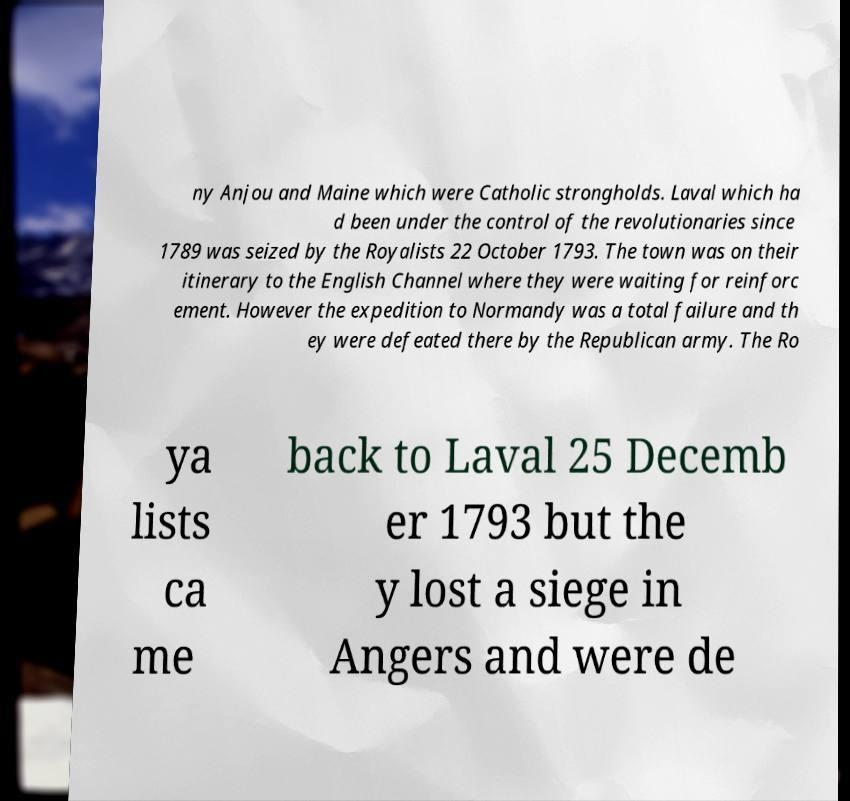There's text embedded in this image that I need extracted. Can you transcribe it verbatim? ny Anjou and Maine which were Catholic strongholds. Laval which ha d been under the control of the revolutionaries since 1789 was seized by the Royalists 22 October 1793. The town was on their itinerary to the English Channel where they were waiting for reinforc ement. However the expedition to Normandy was a total failure and th ey were defeated there by the Republican army. The Ro ya lists ca me back to Laval 25 Decemb er 1793 but the y lost a siege in Angers and were de 